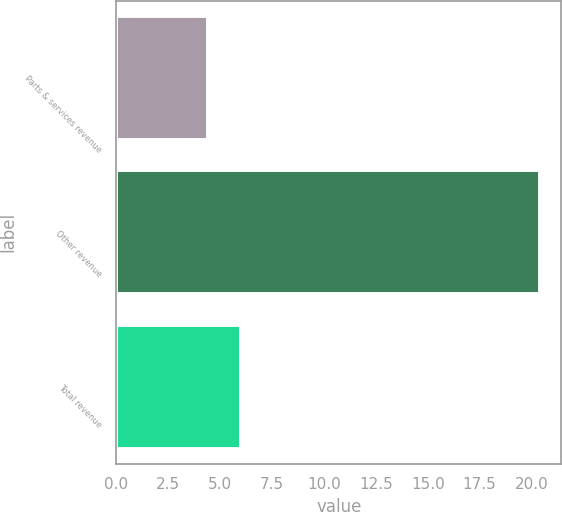Convert chart to OTSL. <chart><loc_0><loc_0><loc_500><loc_500><bar_chart><fcel>Parts & services revenue<fcel>Other revenue<fcel>Total revenue<nl><fcel>4.4<fcel>20.4<fcel>6<nl></chart> 